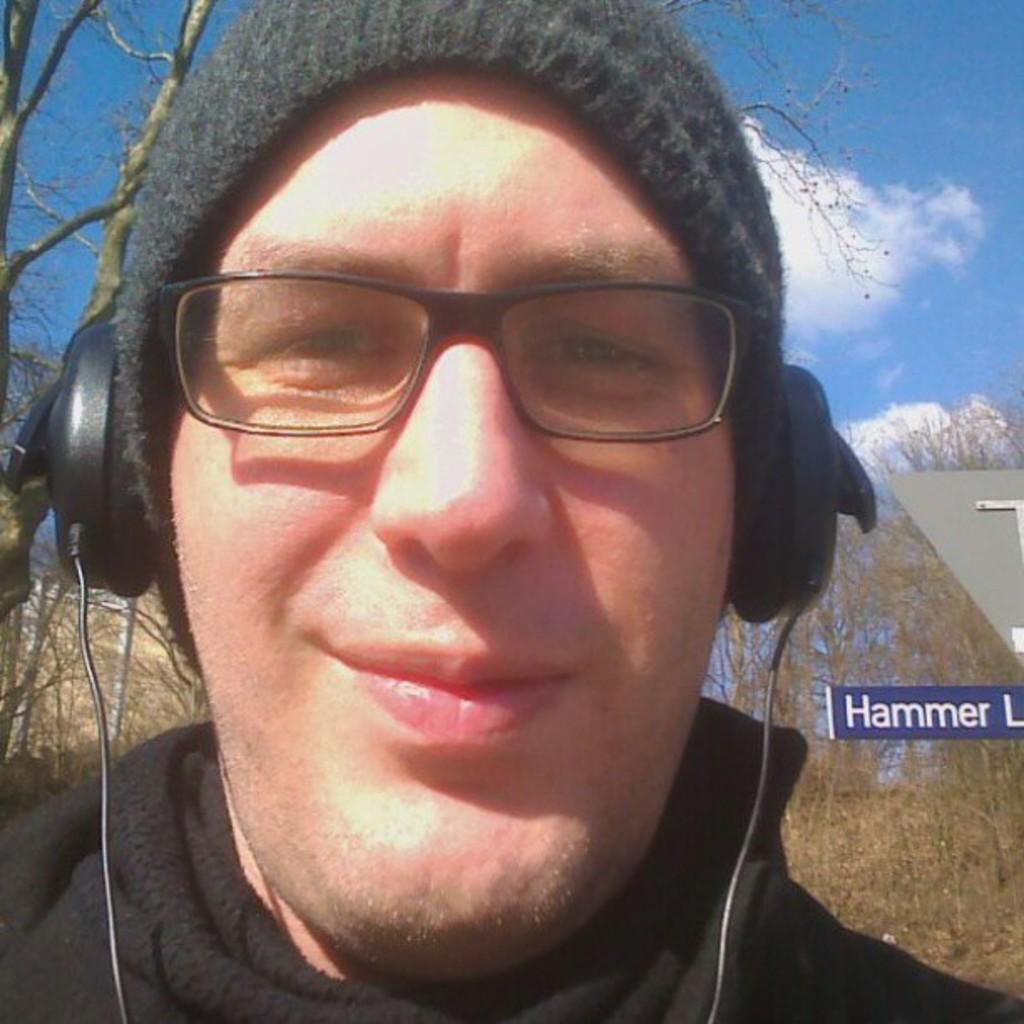What is the main subject of the image? There is a person in the image. What is the person wearing on their head? The person is wearing a cap. What other accessories can be seen on the person? The person is wearing spectacles and headsets. What can be seen in the background of the image? There are trees, a blue-colored board, and the sky visible in the background of the image. What type of crow can be seen in the image? There is no crow present in the image. What kind of breakfast is the person eating in the image? There is no breakfast visible in the image. 